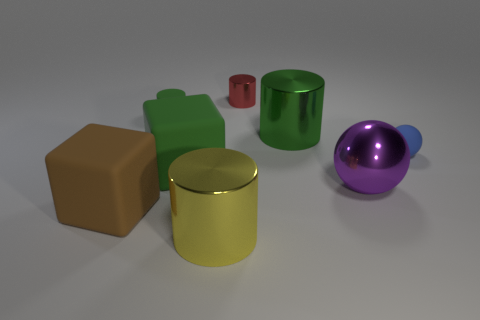Subtract 1 balls. How many balls are left? 1 Subtract all cyan cylinders. Subtract all red blocks. How many cylinders are left? 4 Add 1 purple spheres. How many objects exist? 9 Subtract all balls. How many objects are left? 6 Add 7 big purple rubber cylinders. How many big purple rubber cylinders exist? 7 Subtract 1 yellow cylinders. How many objects are left? 7 Subtract all big purple objects. Subtract all cyan cubes. How many objects are left? 7 Add 5 small red objects. How many small red objects are left? 6 